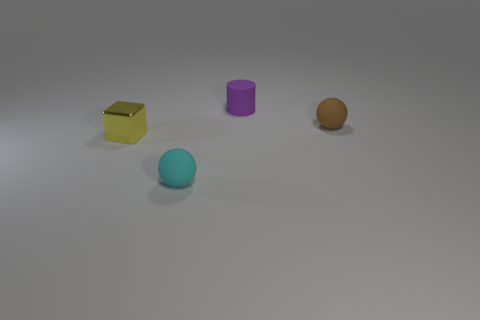How many things are either objects to the right of the small cylinder or small balls that are right of the purple cylinder?
Give a very brief answer. 1. Are there more matte objects that are left of the tiny cylinder than tiny blue cylinders?
Keep it short and to the point. Yes. How many other things are the same shape as the small yellow object?
Your answer should be very brief. 0. There is a thing that is both on the left side of the cylinder and behind the small cyan object; what material is it made of?
Offer a very short reply. Metal. How many objects are small purple rubber things or gray things?
Your answer should be compact. 1. Is the number of cyan rubber spheres greater than the number of small objects?
Ensure brevity in your answer.  No. There is another tiny matte object that is the same shape as the cyan matte thing; what is its color?
Your answer should be compact. Brown. What number of cylinders are small brown matte objects or tiny yellow things?
Offer a terse response. 0. There is a cyan matte thing that is the same shape as the tiny brown thing; what is its size?
Give a very brief answer. Small. How many blue metallic balls are there?
Offer a very short reply. 0. 